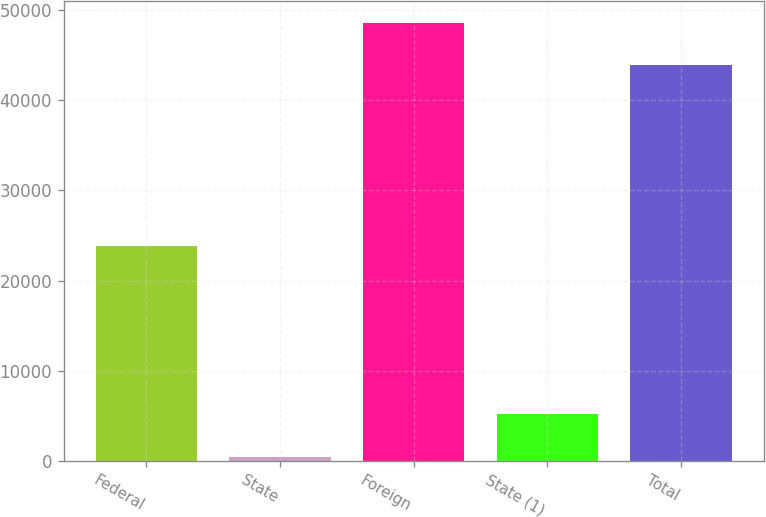<chart> <loc_0><loc_0><loc_500><loc_500><bar_chart><fcel>Federal<fcel>State<fcel>Foreign<fcel>State (1)<fcel>Total<nl><fcel>23835<fcel>476<fcel>48573.3<fcel>5186.3<fcel>43863<nl></chart> 